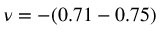Convert formula to latex. <formula><loc_0><loc_0><loc_500><loc_500>\nu = - ( 0 . 7 1 - 0 . 7 5 )</formula> 